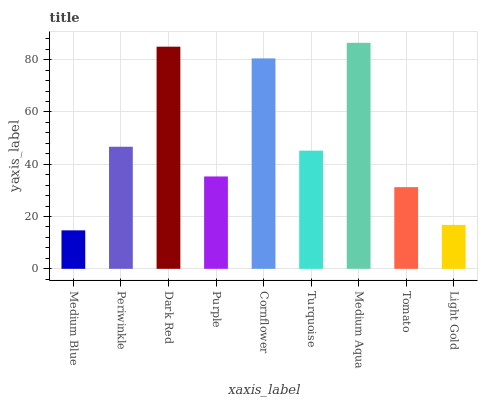Is Medium Blue the minimum?
Answer yes or no. Yes. Is Medium Aqua the maximum?
Answer yes or no. Yes. Is Periwinkle the minimum?
Answer yes or no. No. Is Periwinkle the maximum?
Answer yes or no. No. Is Periwinkle greater than Medium Blue?
Answer yes or no. Yes. Is Medium Blue less than Periwinkle?
Answer yes or no. Yes. Is Medium Blue greater than Periwinkle?
Answer yes or no. No. Is Periwinkle less than Medium Blue?
Answer yes or no. No. Is Turquoise the high median?
Answer yes or no. Yes. Is Turquoise the low median?
Answer yes or no. Yes. Is Medium Blue the high median?
Answer yes or no. No. Is Dark Red the low median?
Answer yes or no. No. 